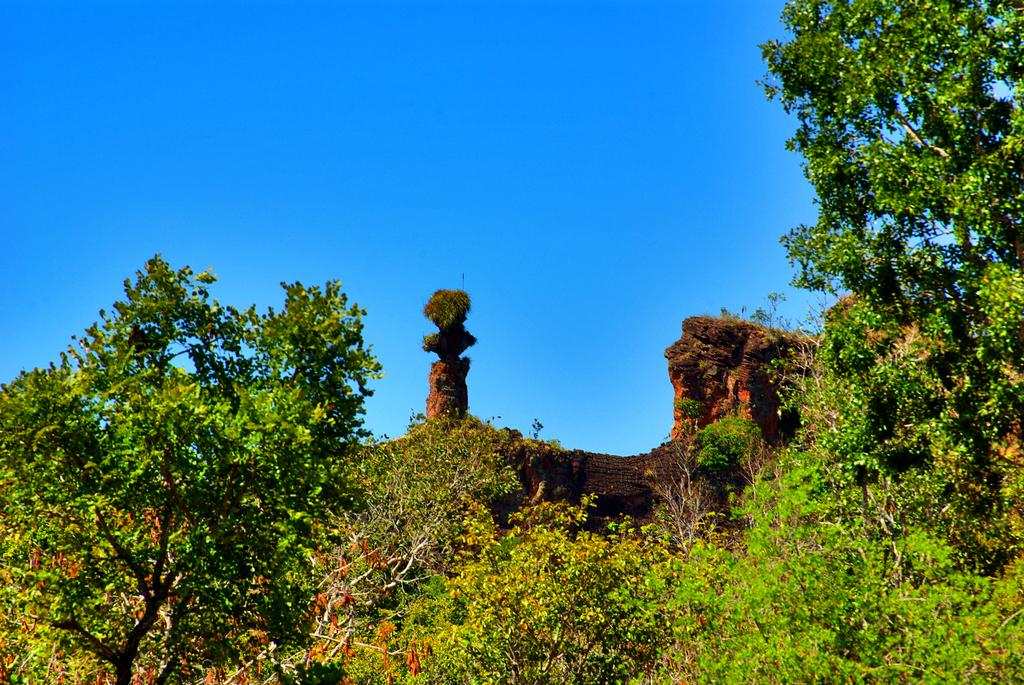What type of natural elements can be seen in the image? There are trees in the image. What man-made structure is present in the image? There is a wall-like structure in the front of the image. What is visible at the top of the image? The sky is visible at the top of the image. How many eyes can be seen on the trees in the image? Trees do not have eyes, so there are no eyes visible on the trees in the image. What type of marble is used to construct the wall-like structure in the image? The wall-like structure is not made of marble; it is not mentioned in the provided facts. 